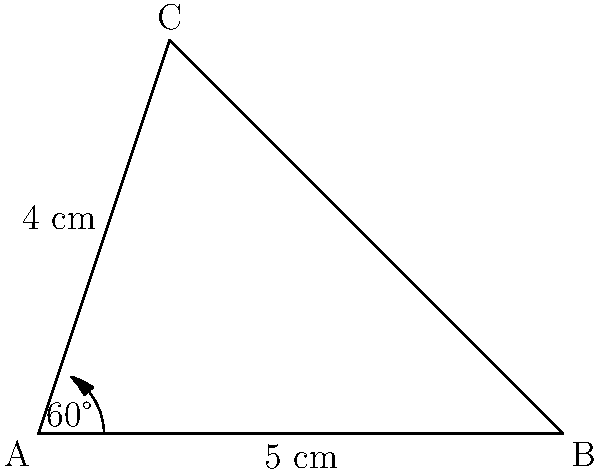In a medieval heraldry workshop, you're designing a triangular pennant for a noble family. The pennant has a base of 5 cm and one side of 4 cm, with an angle of 60° between them. Calculate the area of this triangular pennant to the nearest square centimeter. To find the area of the triangular pennant, we can use the formula:

$$A = \frac{1}{2}ab\sin(C)$$

Where:
$A$ = Area of the triangle
$a$ and $b$ = The two known sides
$C$ = The angle between the known sides

Given:
$a = 5$ cm (base)
$b = 4$ cm (side)
$C = 60°$

Step 1: Substitute the values into the formula:
$$A = \frac{1}{2} \times 5 \times 4 \times \sin(60°)$$

Step 2: Calculate $\sin(60°)$:
$\sin(60°) = \frac{\sqrt{3}}{2} \approx 0.866$

Step 3: Substitute this value and calculate:
$$A = \frac{1}{2} \times 5 \times 4 \times 0.866$$
$$A = 10 \times 0.866 = 8.66 \text{ cm}^2$$

Step 4: Round to the nearest square centimeter:
$A \approx 9 \text{ cm}^2$
Answer: 9 cm² 